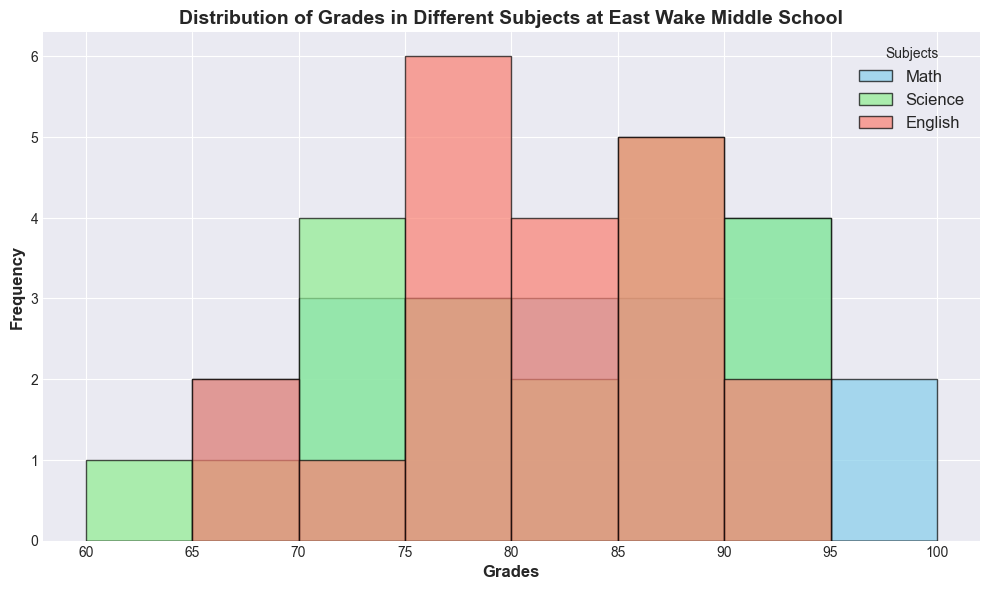How many students scored between 80 and 90 in Math? To answer this, look at the Math histogram and count the bars between the grades 80 and 90. Count the values within the bins that cover 80 to 85 and 85 to 90.
Answer: 4 Which subject has the highest frequency of students scoring above 90? Observe the histograms and identify the bar height for grades above 90. Determine which subject's bar for scores above 90 is the highest.
Answer: Math In which subject do the majority of students score between 70 and 80? Examine the frequency of the bars between 70 and 80 for each subject and compare their heights. The subject with the tallest bar in this interval reflects the majority.
Answer: Science What is the difference in frequency of students scoring above 85 between Math and English? Look at the bars for grades higher than 85 for both Math and English, count the frequency for each, and subtract English's frequency from Math's frequency.
Answer: 1 For grades between 60 and 70, which subject has the lowest frequency? Check the bars for the 60 to 70 range for all subjects and identify which subject has the shortest bar (or no bar at all).
Answer: Science What is the average frequency of students scoring in the 70-80 range across all subjects? Add the frequencies of the bars in the 70-80 range for Math, Science, and English. Then divide the total frequency by 3 to find the average.
Answer: 3.67 Compare the number of students scoring between 85 and 90 in English to Science. Which subject has more students in this range? Count the heights of the bars in the 85-90 range for English and Science and compare their values.
Answer: Science Which subject shows a large cluster of scores between 90 to 95? Identify the histograms and focus on the range of 90 to 95. Compare the bars and select the subject with a concentrated frequency in that range.
Answer: Math How does the distribution of grades in English compare to Math? Visually compare the spread and frequency of scores across the bars in the histograms for Math and English. Describe the general trend, peaks, and spreads of each subject.
Answer: Math has more high scores and greater spread Which subject has the least variability in student grades? Identify the histograms and examine the spread and concentration of the bars. The subject with the bars concentrated in a narrower range indicates the least variability.
Answer: English 